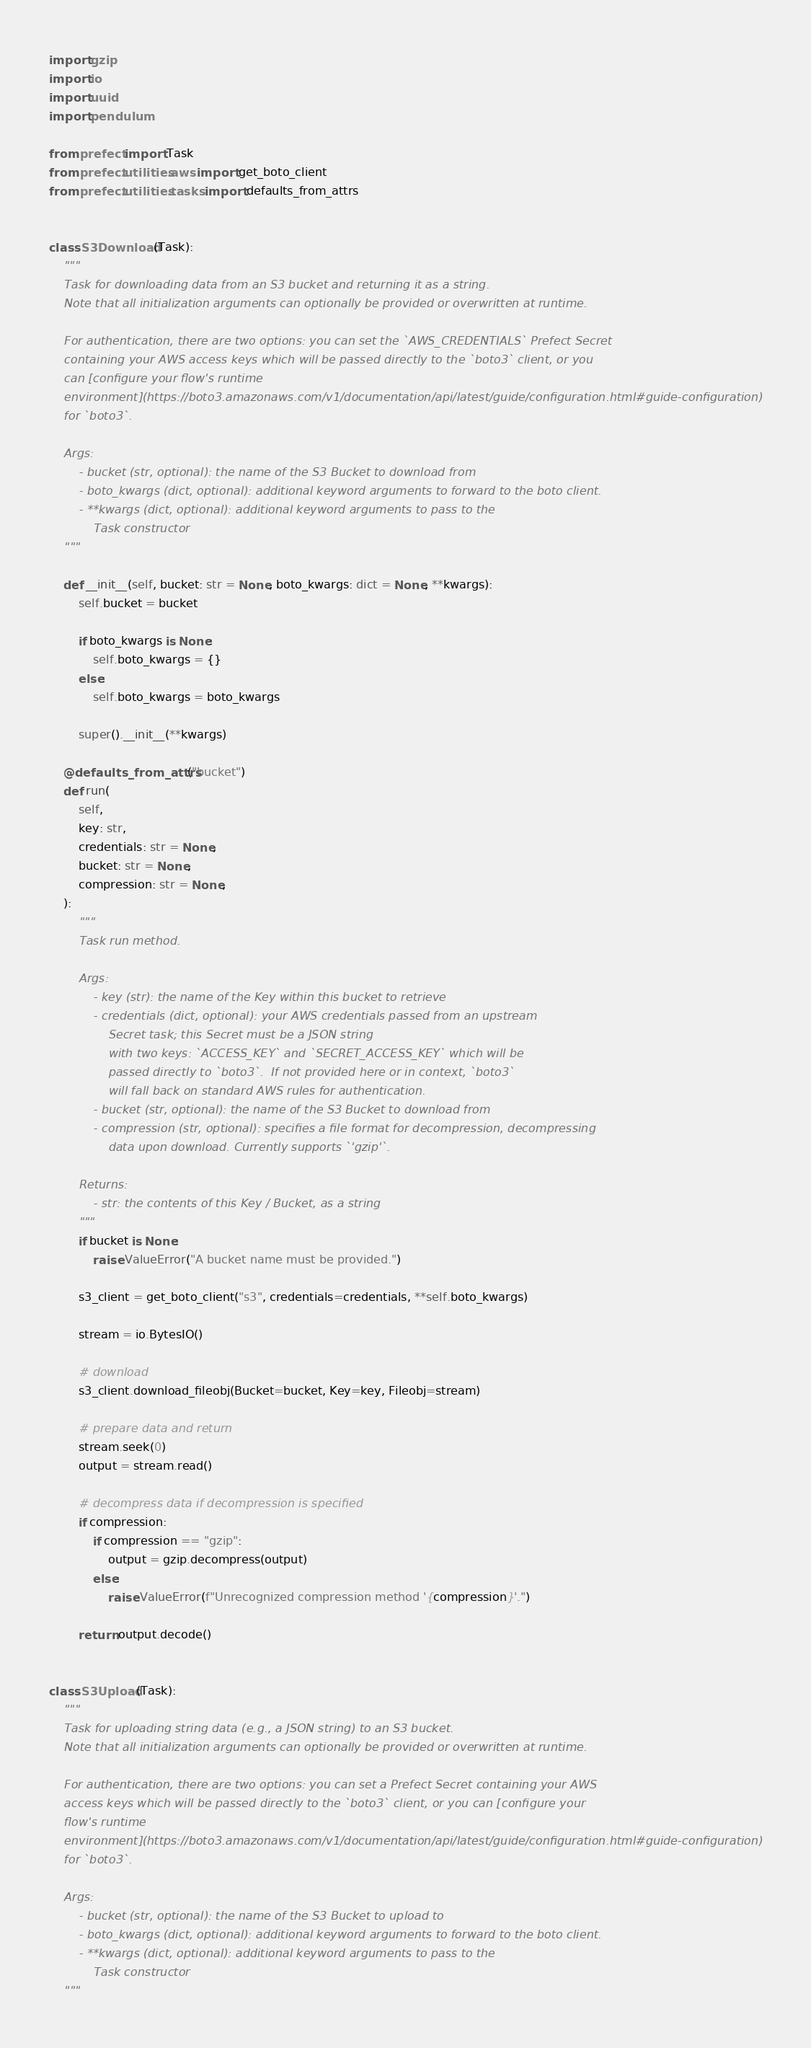<code> <loc_0><loc_0><loc_500><loc_500><_Python_>import gzip
import io
import uuid
import pendulum

from prefect import Task
from prefect.utilities.aws import get_boto_client
from prefect.utilities.tasks import defaults_from_attrs


class S3Download(Task):
    """
    Task for downloading data from an S3 bucket and returning it as a string.
    Note that all initialization arguments can optionally be provided or overwritten at runtime.

    For authentication, there are two options: you can set the `AWS_CREDENTIALS` Prefect Secret
    containing your AWS access keys which will be passed directly to the `boto3` client, or you
    can [configure your flow's runtime
    environment](https://boto3.amazonaws.com/v1/documentation/api/latest/guide/configuration.html#guide-configuration)
    for `boto3`.

    Args:
        - bucket (str, optional): the name of the S3 Bucket to download from
        - boto_kwargs (dict, optional): additional keyword arguments to forward to the boto client.
        - **kwargs (dict, optional): additional keyword arguments to pass to the
            Task constructor
    """

    def __init__(self, bucket: str = None, boto_kwargs: dict = None, **kwargs):
        self.bucket = bucket

        if boto_kwargs is None:
            self.boto_kwargs = {}
        else:
            self.boto_kwargs = boto_kwargs

        super().__init__(**kwargs)

    @defaults_from_attrs("bucket")
    def run(
        self,
        key: str,
        credentials: str = None,
        bucket: str = None,
        compression: str = None,
    ):
        """
        Task run method.

        Args:
            - key (str): the name of the Key within this bucket to retrieve
            - credentials (dict, optional): your AWS credentials passed from an upstream
                Secret task; this Secret must be a JSON string
                with two keys: `ACCESS_KEY` and `SECRET_ACCESS_KEY` which will be
                passed directly to `boto3`.  If not provided here or in context, `boto3`
                will fall back on standard AWS rules for authentication.
            - bucket (str, optional): the name of the S3 Bucket to download from
            - compression (str, optional): specifies a file format for decompression, decompressing
                data upon download. Currently supports `'gzip'`.

        Returns:
            - str: the contents of this Key / Bucket, as a string
        """
        if bucket is None:
            raise ValueError("A bucket name must be provided.")

        s3_client = get_boto_client("s3", credentials=credentials, **self.boto_kwargs)

        stream = io.BytesIO()

        # download
        s3_client.download_fileobj(Bucket=bucket, Key=key, Fileobj=stream)

        # prepare data and return
        stream.seek(0)
        output = stream.read()

        # decompress data if decompression is specified
        if compression:
            if compression == "gzip":
                output = gzip.decompress(output)
            else:
                raise ValueError(f"Unrecognized compression method '{compression}'.")

        return output.decode()


class S3Upload(Task):
    """
    Task for uploading string data (e.g., a JSON string) to an S3 bucket.
    Note that all initialization arguments can optionally be provided or overwritten at runtime.

    For authentication, there are two options: you can set a Prefect Secret containing your AWS
    access keys which will be passed directly to the `boto3` client, or you can [configure your
    flow's runtime
    environment](https://boto3.amazonaws.com/v1/documentation/api/latest/guide/configuration.html#guide-configuration)
    for `boto3`.

    Args:
        - bucket (str, optional): the name of the S3 Bucket to upload to
        - boto_kwargs (dict, optional): additional keyword arguments to forward to the boto client.
        - **kwargs (dict, optional): additional keyword arguments to pass to the
            Task constructor
    """
</code> 